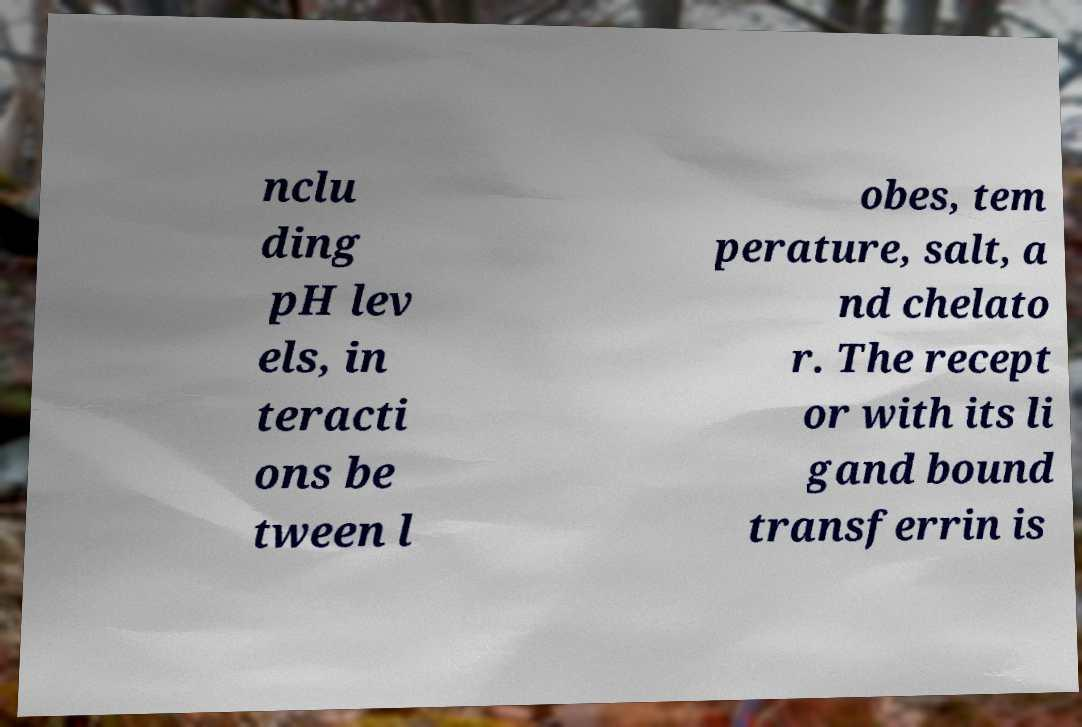Can you accurately transcribe the text from the provided image for me? nclu ding pH lev els, in teracti ons be tween l obes, tem perature, salt, a nd chelato r. The recept or with its li gand bound transferrin is 